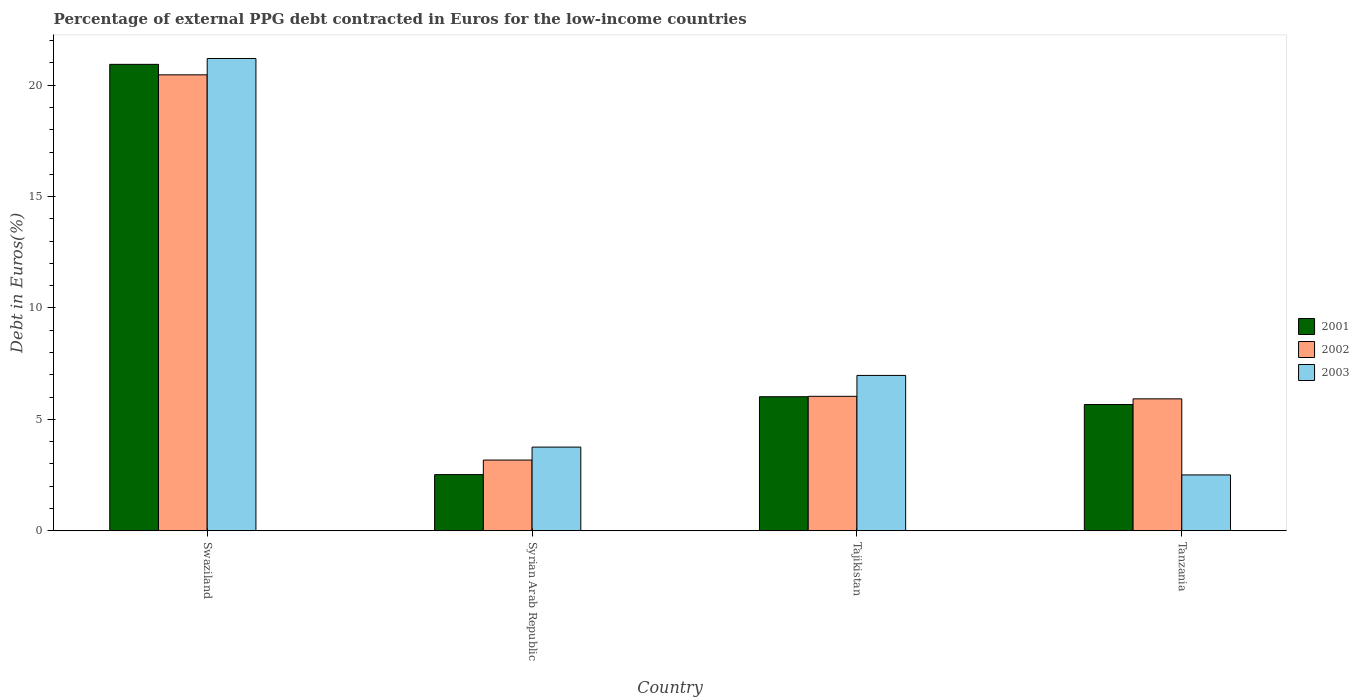How many different coloured bars are there?
Give a very brief answer. 3. How many groups of bars are there?
Offer a terse response. 4. Are the number of bars per tick equal to the number of legend labels?
Your answer should be compact. Yes. What is the label of the 1st group of bars from the left?
Offer a very short reply. Swaziland. In how many cases, is the number of bars for a given country not equal to the number of legend labels?
Offer a terse response. 0. What is the percentage of external PPG debt contracted in Euros in 2003 in Syrian Arab Republic?
Your answer should be very brief. 3.76. Across all countries, what is the maximum percentage of external PPG debt contracted in Euros in 2002?
Provide a succinct answer. 20.47. Across all countries, what is the minimum percentage of external PPG debt contracted in Euros in 2002?
Provide a short and direct response. 3.17. In which country was the percentage of external PPG debt contracted in Euros in 2002 maximum?
Provide a short and direct response. Swaziland. In which country was the percentage of external PPG debt contracted in Euros in 2002 minimum?
Provide a short and direct response. Syrian Arab Republic. What is the total percentage of external PPG debt contracted in Euros in 2002 in the graph?
Offer a terse response. 35.6. What is the difference between the percentage of external PPG debt contracted in Euros in 2001 in Swaziland and that in Syrian Arab Republic?
Ensure brevity in your answer.  18.41. What is the difference between the percentage of external PPG debt contracted in Euros in 2003 in Syrian Arab Republic and the percentage of external PPG debt contracted in Euros in 2001 in Tanzania?
Your answer should be very brief. -1.91. What is the average percentage of external PPG debt contracted in Euros in 2003 per country?
Your answer should be very brief. 8.61. What is the difference between the percentage of external PPG debt contracted in Euros of/in 2002 and percentage of external PPG debt contracted in Euros of/in 2003 in Tanzania?
Keep it short and to the point. 3.41. In how many countries, is the percentage of external PPG debt contracted in Euros in 2003 greater than 19 %?
Make the answer very short. 1. What is the ratio of the percentage of external PPG debt contracted in Euros in 2001 in Tajikistan to that in Tanzania?
Your answer should be compact. 1.06. Is the percentage of external PPG debt contracted in Euros in 2002 in Swaziland less than that in Syrian Arab Republic?
Keep it short and to the point. No. What is the difference between the highest and the second highest percentage of external PPG debt contracted in Euros in 2003?
Your answer should be very brief. -17.44. What is the difference between the highest and the lowest percentage of external PPG debt contracted in Euros in 2002?
Make the answer very short. 17.29. In how many countries, is the percentage of external PPG debt contracted in Euros in 2001 greater than the average percentage of external PPG debt contracted in Euros in 2001 taken over all countries?
Make the answer very short. 1. Is the sum of the percentage of external PPG debt contracted in Euros in 2003 in Swaziland and Tajikistan greater than the maximum percentage of external PPG debt contracted in Euros in 2001 across all countries?
Offer a very short reply. Yes. What does the 1st bar from the right in Tajikistan represents?
Ensure brevity in your answer.  2003. How many bars are there?
Offer a terse response. 12. Are all the bars in the graph horizontal?
Your answer should be very brief. No. What is the difference between two consecutive major ticks on the Y-axis?
Make the answer very short. 5. Are the values on the major ticks of Y-axis written in scientific E-notation?
Ensure brevity in your answer.  No. How are the legend labels stacked?
Your response must be concise. Vertical. What is the title of the graph?
Offer a very short reply. Percentage of external PPG debt contracted in Euros for the low-income countries. Does "2007" appear as one of the legend labels in the graph?
Give a very brief answer. No. What is the label or title of the X-axis?
Your answer should be very brief. Country. What is the label or title of the Y-axis?
Offer a terse response. Debt in Euros(%). What is the Debt in Euros(%) of 2001 in Swaziland?
Your answer should be compact. 20.94. What is the Debt in Euros(%) in 2002 in Swaziland?
Offer a terse response. 20.47. What is the Debt in Euros(%) in 2003 in Swaziland?
Give a very brief answer. 21.2. What is the Debt in Euros(%) in 2001 in Syrian Arab Republic?
Your response must be concise. 2.52. What is the Debt in Euros(%) of 2002 in Syrian Arab Republic?
Your response must be concise. 3.17. What is the Debt in Euros(%) in 2003 in Syrian Arab Republic?
Provide a succinct answer. 3.76. What is the Debt in Euros(%) in 2001 in Tajikistan?
Ensure brevity in your answer.  6.02. What is the Debt in Euros(%) in 2002 in Tajikistan?
Your answer should be very brief. 6.04. What is the Debt in Euros(%) in 2003 in Tajikistan?
Offer a terse response. 6.97. What is the Debt in Euros(%) in 2001 in Tanzania?
Offer a terse response. 5.67. What is the Debt in Euros(%) of 2002 in Tanzania?
Your response must be concise. 5.92. What is the Debt in Euros(%) of 2003 in Tanzania?
Your answer should be very brief. 2.51. Across all countries, what is the maximum Debt in Euros(%) in 2001?
Keep it short and to the point. 20.94. Across all countries, what is the maximum Debt in Euros(%) in 2002?
Your answer should be compact. 20.47. Across all countries, what is the maximum Debt in Euros(%) in 2003?
Provide a short and direct response. 21.2. Across all countries, what is the minimum Debt in Euros(%) of 2001?
Give a very brief answer. 2.52. Across all countries, what is the minimum Debt in Euros(%) of 2002?
Your response must be concise. 3.17. Across all countries, what is the minimum Debt in Euros(%) in 2003?
Provide a short and direct response. 2.51. What is the total Debt in Euros(%) of 2001 in the graph?
Your response must be concise. 35.14. What is the total Debt in Euros(%) of 2002 in the graph?
Your answer should be compact. 35.6. What is the total Debt in Euros(%) of 2003 in the graph?
Offer a very short reply. 34.44. What is the difference between the Debt in Euros(%) in 2001 in Swaziland and that in Syrian Arab Republic?
Your answer should be very brief. 18.41. What is the difference between the Debt in Euros(%) of 2002 in Swaziland and that in Syrian Arab Republic?
Your response must be concise. 17.29. What is the difference between the Debt in Euros(%) in 2003 in Swaziland and that in Syrian Arab Republic?
Ensure brevity in your answer.  17.44. What is the difference between the Debt in Euros(%) in 2001 in Swaziland and that in Tajikistan?
Offer a terse response. 14.92. What is the difference between the Debt in Euros(%) in 2002 in Swaziland and that in Tajikistan?
Keep it short and to the point. 14.43. What is the difference between the Debt in Euros(%) of 2003 in Swaziland and that in Tajikistan?
Your answer should be very brief. 14.23. What is the difference between the Debt in Euros(%) in 2001 in Swaziland and that in Tanzania?
Ensure brevity in your answer.  15.27. What is the difference between the Debt in Euros(%) of 2002 in Swaziland and that in Tanzania?
Ensure brevity in your answer.  14.54. What is the difference between the Debt in Euros(%) of 2003 in Swaziland and that in Tanzania?
Offer a terse response. 18.69. What is the difference between the Debt in Euros(%) of 2001 in Syrian Arab Republic and that in Tajikistan?
Ensure brevity in your answer.  -3.5. What is the difference between the Debt in Euros(%) of 2002 in Syrian Arab Republic and that in Tajikistan?
Your answer should be very brief. -2.86. What is the difference between the Debt in Euros(%) of 2003 in Syrian Arab Republic and that in Tajikistan?
Provide a short and direct response. -3.22. What is the difference between the Debt in Euros(%) of 2001 in Syrian Arab Republic and that in Tanzania?
Offer a terse response. -3.15. What is the difference between the Debt in Euros(%) of 2002 in Syrian Arab Republic and that in Tanzania?
Give a very brief answer. -2.75. What is the difference between the Debt in Euros(%) in 2003 in Syrian Arab Republic and that in Tanzania?
Provide a short and direct response. 1.25. What is the difference between the Debt in Euros(%) in 2001 in Tajikistan and that in Tanzania?
Provide a short and direct response. 0.35. What is the difference between the Debt in Euros(%) in 2002 in Tajikistan and that in Tanzania?
Offer a terse response. 0.11. What is the difference between the Debt in Euros(%) in 2003 in Tajikistan and that in Tanzania?
Provide a short and direct response. 4.47. What is the difference between the Debt in Euros(%) of 2001 in Swaziland and the Debt in Euros(%) of 2002 in Syrian Arab Republic?
Provide a short and direct response. 17.76. What is the difference between the Debt in Euros(%) of 2001 in Swaziland and the Debt in Euros(%) of 2003 in Syrian Arab Republic?
Offer a terse response. 17.18. What is the difference between the Debt in Euros(%) of 2002 in Swaziland and the Debt in Euros(%) of 2003 in Syrian Arab Republic?
Your answer should be compact. 16.71. What is the difference between the Debt in Euros(%) of 2001 in Swaziland and the Debt in Euros(%) of 2002 in Tajikistan?
Your response must be concise. 14.9. What is the difference between the Debt in Euros(%) of 2001 in Swaziland and the Debt in Euros(%) of 2003 in Tajikistan?
Ensure brevity in your answer.  13.96. What is the difference between the Debt in Euros(%) of 2002 in Swaziland and the Debt in Euros(%) of 2003 in Tajikistan?
Your answer should be very brief. 13.49. What is the difference between the Debt in Euros(%) of 2001 in Swaziland and the Debt in Euros(%) of 2002 in Tanzania?
Ensure brevity in your answer.  15.01. What is the difference between the Debt in Euros(%) in 2001 in Swaziland and the Debt in Euros(%) in 2003 in Tanzania?
Your answer should be compact. 18.43. What is the difference between the Debt in Euros(%) in 2002 in Swaziland and the Debt in Euros(%) in 2003 in Tanzania?
Ensure brevity in your answer.  17.96. What is the difference between the Debt in Euros(%) in 2001 in Syrian Arab Republic and the Debt in Euros(%) in 2002 in Tajikistan?
Provide a short and direct response. -3.51. What is the difference between the Debt in Euros(%) of 2001 in Syrian Arab Republic and the Debt in Euros(%) of 2003 in Tajikistan?
Provide a short and direct response. -4.45. What is the difference between the Debt in Euros(%) of 2002 in Syrian Arab Republic and the Debt in Euros(%) of 2003 in Tajikistan?
Provide a succinct answer. -3.8. What is the difference between the Debt in Euros(%) of 2001 in Syrian Arab Republic and the Debt in Euros(%) of 2002 in Tanzania?
Your answer should be very brief. -3.4. What is the difference between the Debt in Euros(%) of 2001 in Syrian Arab Republic and the Debt in Euros(%) of 2003 in Tanzania?
Provide a succinct answer. 0.02. What is the difference between the Debt in Euros(%) in 2002 in Syrian Arab Republic and the Debt in Euros(%) in 2003 in Tanzania?
Offer a terse response. 0.67. What is the difference between the Debt in Euros(%) of 2001 in Tajikistan and the Debt in Euros(%) of 2002 in Tanzania?
Your answer should be compact. 0.1. What is the difference between the Debt in Euros(%) in 2001 in Tajikistan and the Debt in Euros(%) in 2003 in Tanzania?
Ensure brevity in your answer.  3.51. What is the difference between the Debt in Euros(%) in 2002 in Tajikistan and the Debt in Euros(%) in 2003 in Tanzania?
Ensure brevity in your answer.  3.53. What is the average Debt in Euros(%) in 2001 per country?
Keep it short and to the point. 8.79. What is the average Debt in Euros(%) in 2002 per country?
Your answer should be very brief. 8.9. What is the average Debt in Euros(%) in 2003 per country?
Provide a short and direct response. 8.61. What is the difference between the Debt in Euros(%) in 2001 and Debt in Euros(%) in 2002 in Swaziland?
Your response must be concise. 0.47. What is the difference between the Debt in Euros(%) in 2001 and Debt in Euros(%) in 2003 in Swaziland?
Provide a short and direct response. -0.26. What is the difference between the Debt in Euros(%) in 2002 and Debt in Euros(%) in 2003 in Swaziland?
Your answer should be compact. -0.73. What is the difference between the Debt in Euros(%) of 2001 and Debt in Euros(%) of 2002 in Syrian Arab Republic?
Your response must be concise. -0.65. What is the difference between the Debt in Euros(%) of 2001 and Debt in Euros(%) of 2003 in Syrian Arab Republic?
Make the answer very short. -1.23. What is the difference between the Debt in Euros(%) of 2002 and Debt in Euros(%) of 2003 in Syrian Arab Republic?
Give a very brief answer. -0.58. What is the difference between the Debt in Euros(%) of 2001 and Debt in Euros(%) of 2002 in Tajikistan?
Give a very brief answer. -0.02. What is the difference between the Debt in Euros(%) in 2001 and Debt in Euros(%) in 2003 in Tajikistan?
Offer a terse response. -0.96. What is the difference between the Debt in Euros(%) of 2002 and Debt in Euros(%) of 2003 in Tajikistan?
Give a very brief answer. -0.94. What is the difference between the Debt in Euros(%) of 2001 and Debt in Euros(%) of 2002 in Tanzania?
Provide a short and direct response. -0.25. What is the difference between the Debt in Euros(%) in 2001 and Debt in Euros(%) in 2003 in Tanzania?
Provide a short and direct response. 3.16. What is the difference between the Debt in Euros(%) in 2002 and Debt in Euros(%) in 2003 in Tanzania?
Provide a short and direct response. 3.41. What is the ratio of the Debt in Euros(%) of 2001 in Swaziland to that in Syrian Arab Republic?
Make the answer very short. 8.3. What is the ratio of the Debt in Euros(%) of 2002 in Swaziland to that in Syrian Arab Republic?
Offer a terse response. 6.45. What is the ratio of the Debt in Euros(%) in 2003 in Swaziland to that in Syrian Arab Republic?
Keep it short and to the point. 5.64. What is the ratio of the Debt in Euros(%) in 2001 in Swaziland to that in Tajikistan?
Your answer should be compact. 3.48. What is the ratio of the Debt in Euros(%) of 2002 in Swaziland to that in Tajikistan?
Make the answer very short. 3.39. What is the ratio of the Debt in Euros(%) of 2003 in Swaziland to that in Tajikistan?
Keep it short and to the point. 3.04. What is the ratio of the Debt in Euros(%) in 2001 in Swaziland to that in Tanzania?
Your response must be concise. 3.69. What is the ratio of the Debt in Euros(%) of 2002 in Swaziland to that in Tanzania?
Keep it short and to the point. 3.46. What is the ratio of the Debt in Euros(%) in 2003 in Swaziland to that in Tanzania?
Give a very brief answer. 8.46. What is the ratio of the Debt in Euros(%) in 2001 in Syrian Arab Republic to that in Tajikistan?
Your answer should be very brief. 0.42. What is the ratio of the Debt in Euros(%) of 2002 in Syrian Arab Republic to that in Tajikistan?
Your answer should be compact. 0.53. What is the ratio of the Debt in Euros(%) of 2003 in Syrian Arab Republic to that in Tajikistan?
Offer a very short reply. 0.54. What is the ratio of the Debt in Euros(%) of 2001 in Syrian Arab Republic to that in Tanzania?
Keep it short and to the point. 0.45. What is the ratio of the Debt in Euros(%) in 2002 in Syrian Arab Republic to that in Tanzania?
Make the answer very short. 0.54. What is the ratio of the Debt in Euros(%) in 2003 in Syrian Arab Republic to that in Tanzania?
Your answer should be very brief. 1.5. What is the ratio of the Debt in Euros(%) in 2001 in Tajikistan to that in Tanzania?
Your answer should be compact. 1.06. What is the ratio of the Debt in Euros(%) in 2002 in Tajikistan to that in Tanzania?
Keep it short and to the point. 1.02. What is the ratio of the Debt in Euros(%) in 2003 in Tajikistan to that in Tanzania?
Make the answer very short. 2.78. What is the difference between the highest and the second highest Debt in Euros(%) in 2001?
Your answer should be compact. 14.92. What is the difference between the highest and the second highest Debt in Euros(%) in 2002?
Provide a short and direct response. 14.43. What is the difference between the highest and the second highest Debt in Euros(%) of 2003?
Your answer should be compact. 14.23. What is the difference between the highest and the lowest Debt in Euros(%) of 2001?
Provide a short and direct response. 18.41. What is the difference between the highest and the lowest Debt in Euros(%) of 2002?
Give a very brief answer. 17.29. What is the difference between the highest and the lowest Debt in Euros(%) in 2003?
Your response must be concise. 18.69. 